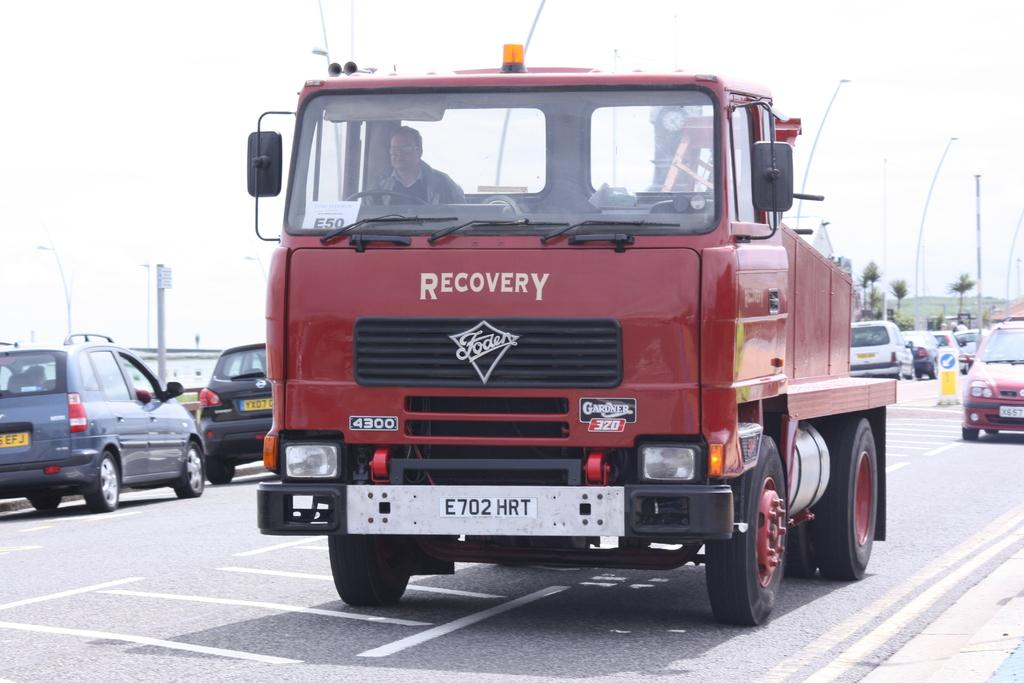What can be seen on the road in the image? There are vehicles on the road in the image. What structures are present in the image? There are poles and lights in the image. What type of vegetation is visible in the image? There are trees in the image. What objects resemble boards in the image? There are objects that look like boards in the image. What is visible in the background of the image? The sky is visible in the background of the image. How many grandmothers are present in the image? There are no grandmothers present in the image. What type of thing is floating in the sky in the image? There is no thing floating in the sky in the image. 